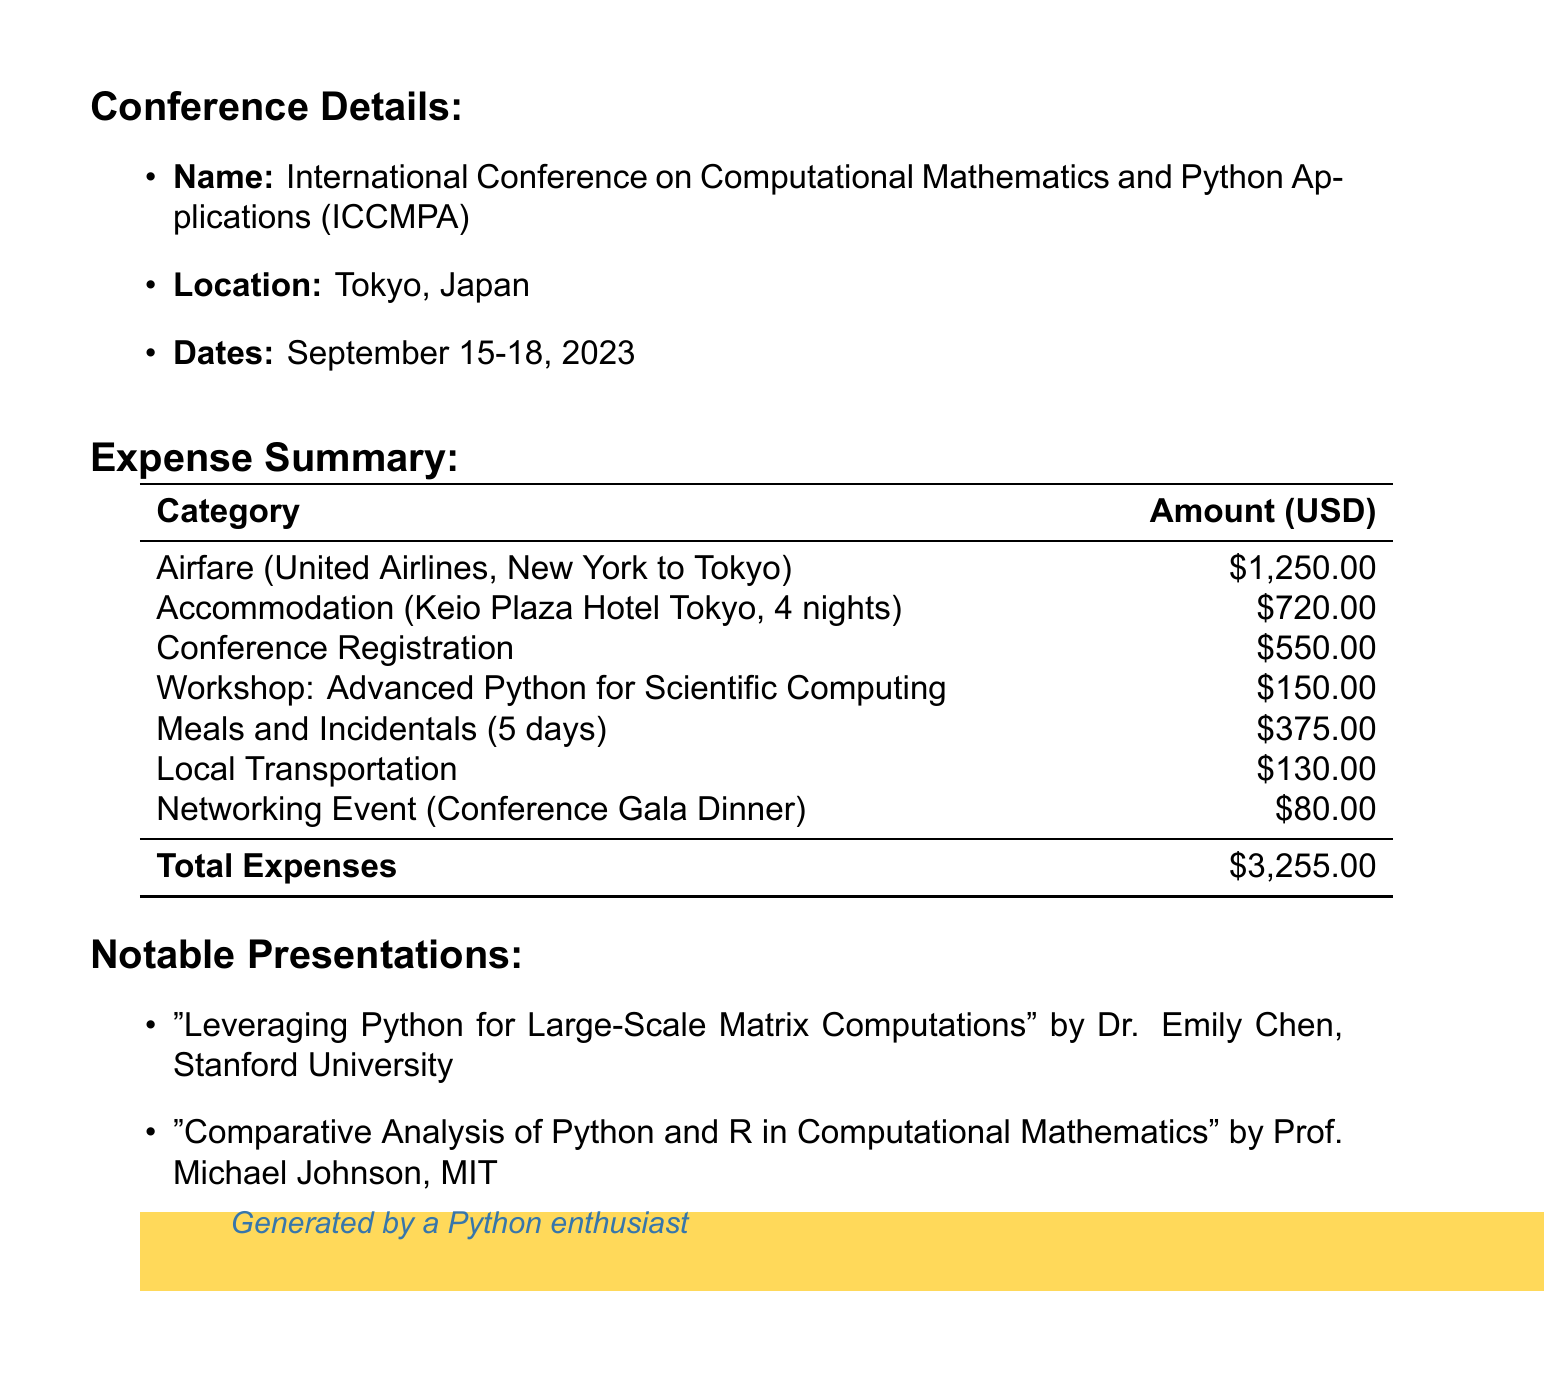What is the conference name? The conference name is provided in the document's Conference Details section.
Answer: International Conference on Computational Mathematics and Python Applications (ICCMPA) What are the dates of the conference? The dates of the conference are explicitly stated under the Conference Details section.
Answer: September 15-18, 2023 What is the total cost of airfare? The airfare cost is listed in the travel expenses section.
Answer: 1250.00 How many nights was the accommodation booked for? The number of nights is stated in the accommodation details within the travel expenses.
Answer: 4 What is the cost of the workshop on Advanced Python? The cost is provided in the conference fees section.
Answer: 150.00 What type of meal expenses are included in the report? It specifies meals and incidentals in the expense summary section.
Answer: Daily allowance What is the total expense of local transportation? The total for local transportation is summarized in the expense section.
Answer: 130.00 Who is the presenter of the presentation titled "Comparative Analysis of Python and R in Computational Mathematics"? The presenter's name is listed in the notable presentations section.
Answer: Prof. Michael Johnson What is the cost of the conference registration fee? The registration fee amount is provided under conference fees in the expense summary.
Answer: 550.00 